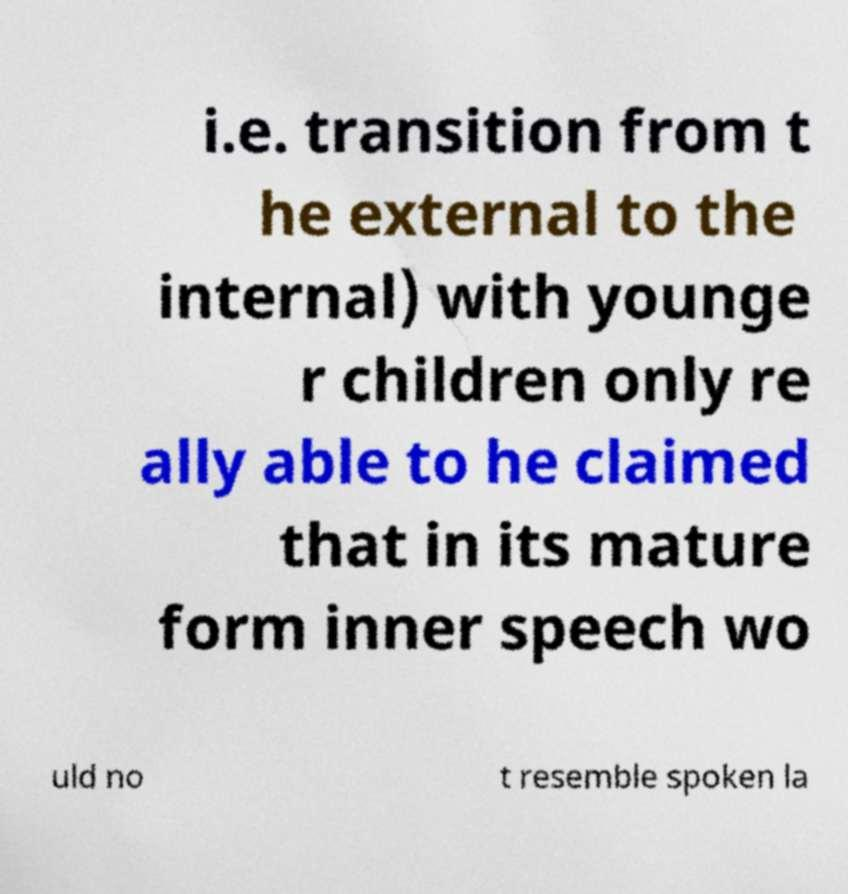I need the written content from this picture converted into text. Can you do that? i.e. transition from t he external to the internal) with younge r children only re ally able to he claimed that in its mature form inner speech wo uld no t resemble spoken la 